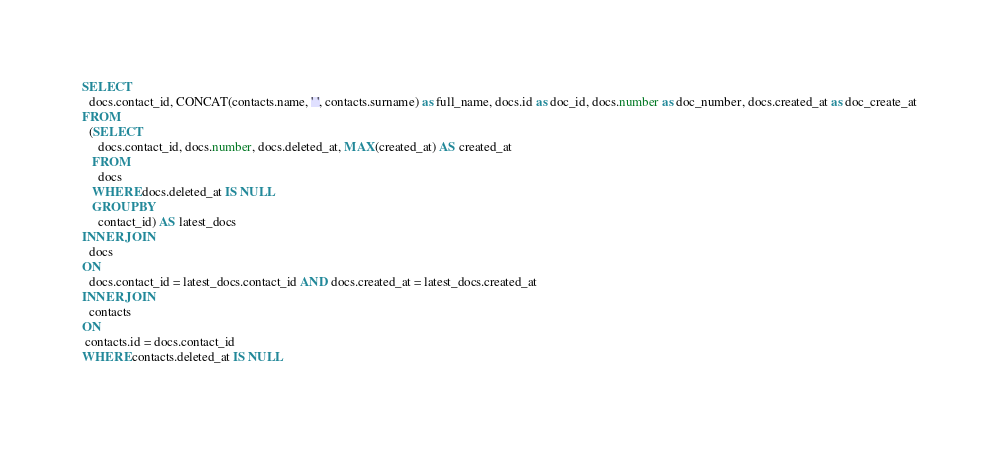<code> <loc_0><loc_0><loc_500><loc_500><_SQL_>SELECT
  docs.contact_id, CONCAT(contacts.name, ' ', contacts.surname) as full_name, docs.id as doc_id, docs.number as doc_number, docs.created_at as doc_create_at
FROM
  (SELECT
     docs.contact_id, docs.number, docs.deleted_at, MAX(created_at) AS created_at
   FROM
     docs
   WHERE docs.deleted_at IS NULL
   GROUP BY
     contact_id) AS latest_docs
INNER JOIN
  docs
ON
  docs.contact_id = latest_docs.contact_id AND docs.created_at = latest_docs.created_at
INNER JOIN
  contacts
ON
 contacts.id = docs.contact_id
WHERE contacts.deleted_at IS NULL</code> 